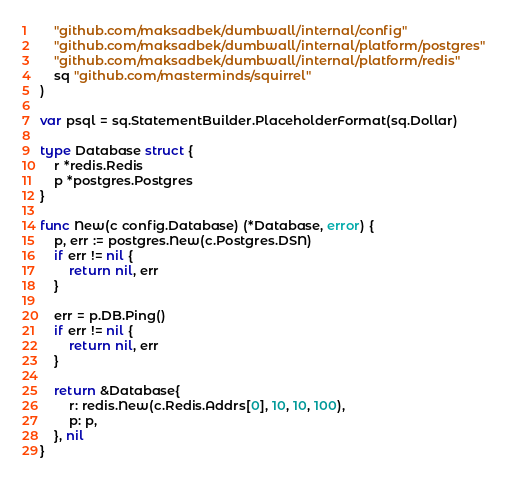<code> <loc_0><loc_0><loc_500><loc_500><_Go_>	"github.com/maksadbek/dumbwall/internal/config"
	"github.com/maksadbek/dumbwall/internal/platform/postgres"
	"github.com/maksadbek/dumbwall/internal/platform/redis"
	sq "github.com/masterminds/squirrel"
)

var psql = sq.StatementBuilder.PlaceholderFormat(sq.Dollar)

type Database struct {
	r *redis.Redis
	p *postgres.Postgres
}

func New(c config.Database) (*Database, error) {
	p, err := postgres.New(c.Postgres.DSN)
	if err != nil {
		return nil, err
	}

	err = p.DB.Ping()
	if err != nil {
		return nil, err
	}

	return &Database{
		r: redis.New(c.Redis.Addrs[0], 10, 10, 100),
		p: p,
	}, nil
}
</code> 